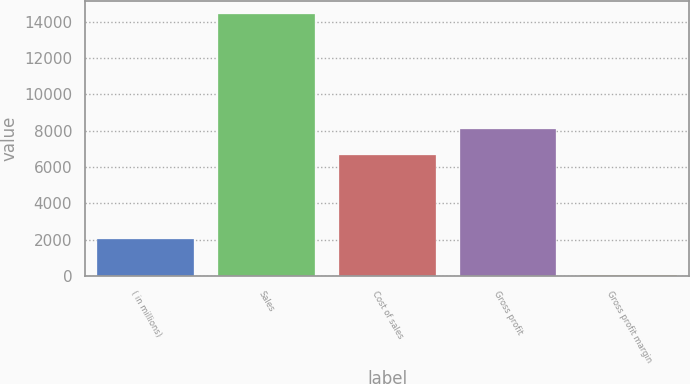<chart> <loc_0><loc_0><loc_500><loc_500><bar_chart><fcel>( in millions)<fcel>Sales<fcel>Cost of sales<fcel>Gross profit<fcel>Gross profit margin<nl><fcel>2015<fcel>14433.7<fcel>6662.6<fcel>8100.59<fcel>53.8<nl></chart> 